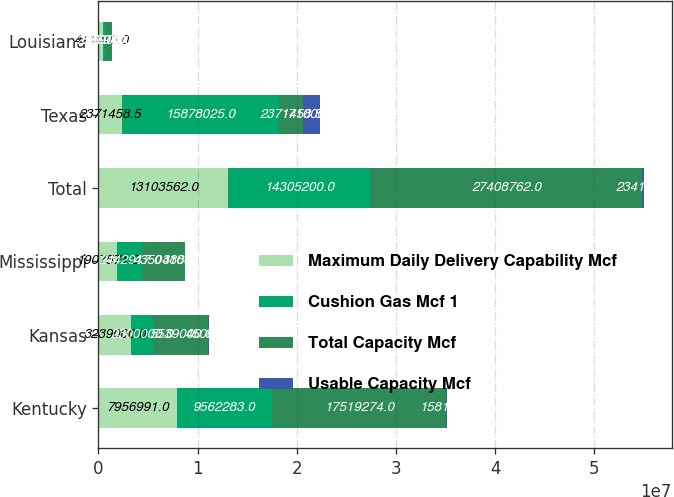Convert chart. <chart><loc_0><loc_0><loc_500><loc_500><stacked_bar_chart><ecel><fcel>Kentucky<fcel>Kansas<fcel>Mississippi<fcel>Total<fcel>Texas<fcel>Louisiana<nl><fcel>Maximum Daily Delivery Capability Mcf<fcel>7.95699e+06<fcel>3.239e+06<fcel>1.90757e+06<fcel>1.31036e+07<fcel>2.37146e+06<fcel>411040<nl><fcel>Cushion Gas Mcf 1<fcel>9.56228e+06<fcel>2.3e+06<fcel>2.44292e+06<fcel>1.43052e+07<fcel>1.5878e+07<fcel>256900<nl><fcel>Total Capacity Mcf<fcel>1.75193e+07<fcel>5.539e+06<fcel>4.35049e+06<fcel>2.74088e+07<fcel>2.37146e+06<fcel>667940<nl><fcel>Usable Capacity Mcf<fcel>158100<fcel>45000<fcel>31000<fcel>234100<fcel>1.71e+06<fcel>56000<nl></chart> 